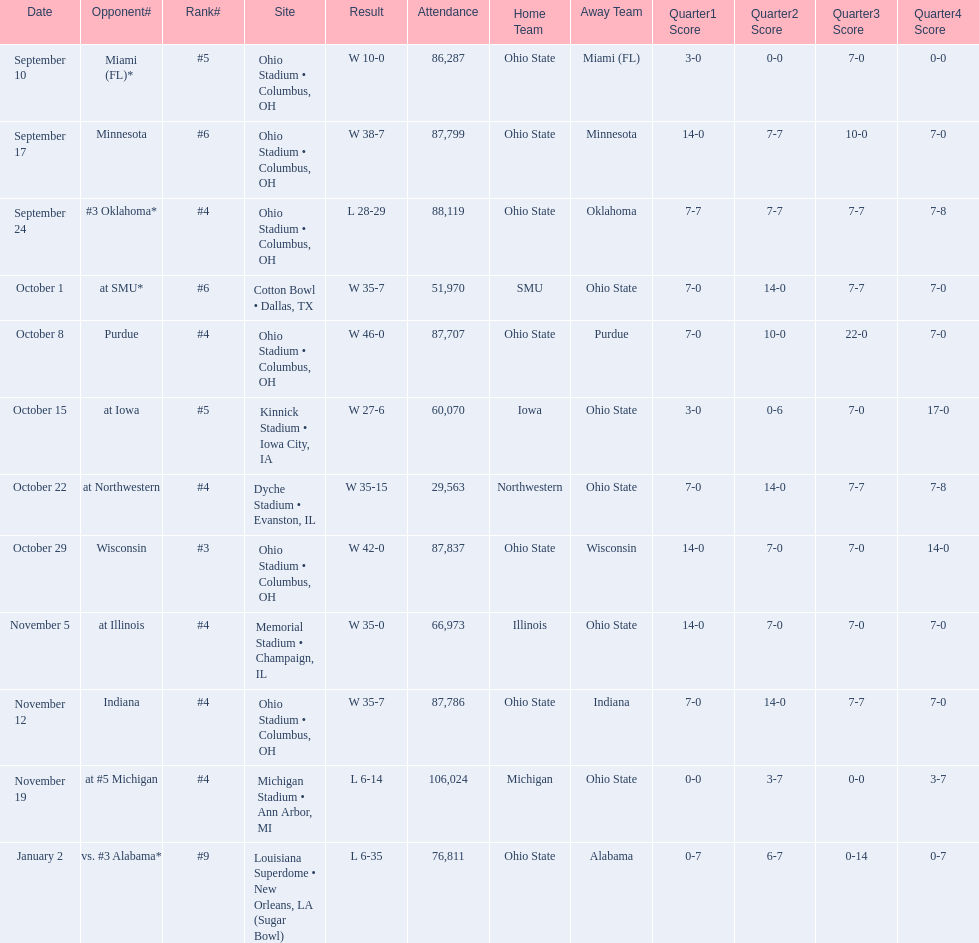How many games did this team win during this season? 9. 